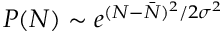<formula> <loc_0><loc_0><loc_500><loc_500>P ( N ) \sim e ^ { ( N - \bar { N } ) ^ { 2 } / 2 \sigma ^ { 2 } }</formula> 